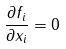<formula> <loc_0><loc_0><loc_500><loc_500>\frac { \partial f _ { i } } { \partial x _ { i } } = 0</formula> 